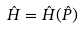Convert formula to latex. <formula><loc_0><loc_0><loc_500><loc_500>\hat { H } = \hat { H } ( \hat { P } )</formula> 